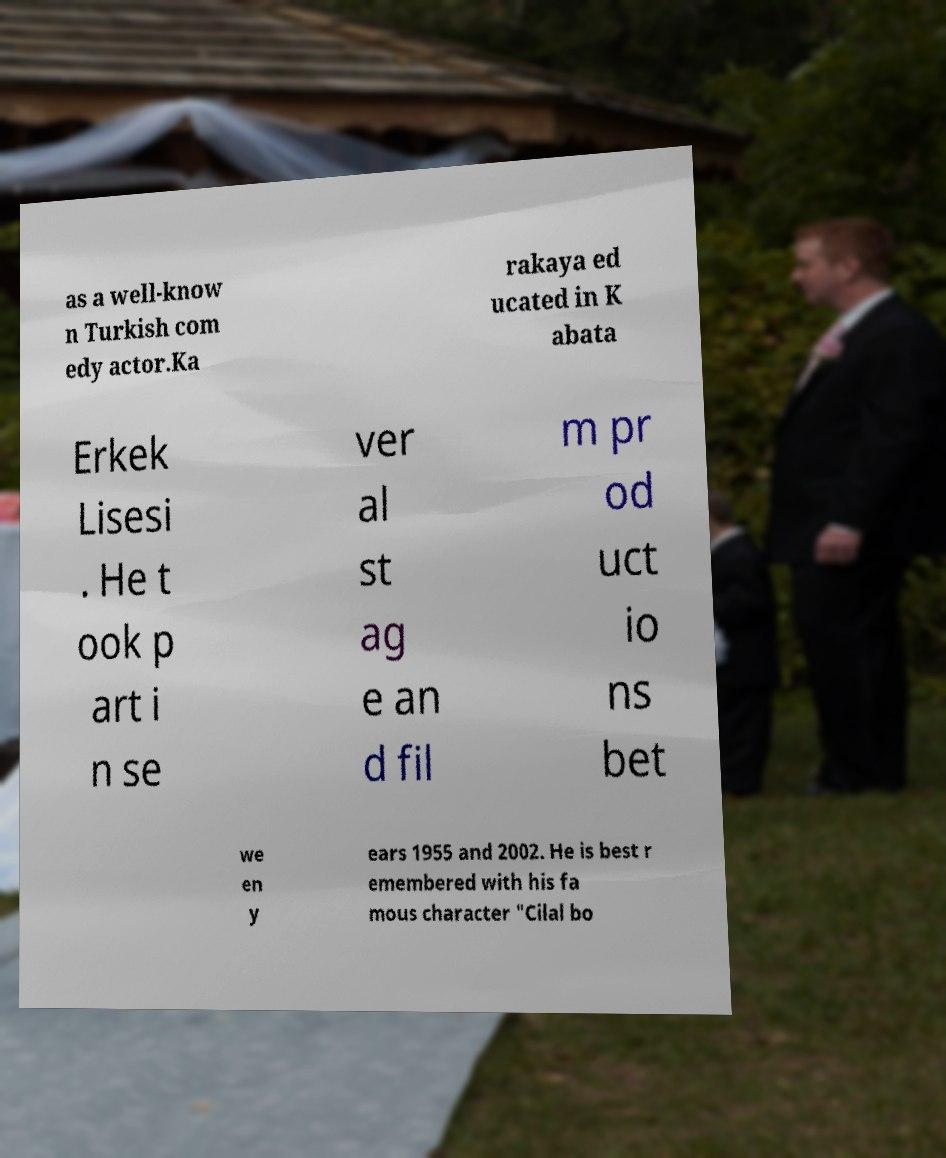What messages or text are displayed in this image? I need them in a readable, typed format. as a well-know n Turkish com edy actor.Ka rakaya ed ucated in K abata Erkek Lisesi . He t ook p art i n se ver al st ag e an d fil m pr od uct io ns bet we en y ears 1955 and 2002. He is best r emembered with his fa mous character "Cilal bo 